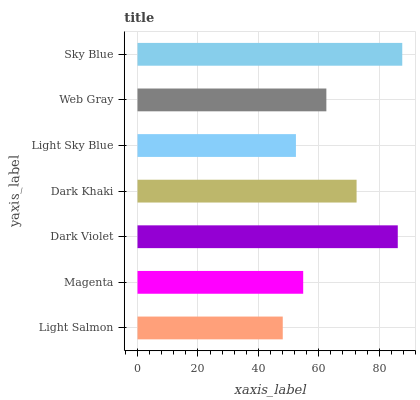Is Light Salmon the minimum?
Answer yes or no. Yes. Is Sky Blue the maximum?
Answer yes or no. Yes. Is Magenta the minimum?
Answer yes or no. No. Is Magenta the maximum?
Answer yes or no. No. Is Magenta greater than Light Salmon?
Answer yes or no. Yes. Is Light Salmon less than Magenta?
Answer yes or no. Yes. Is Light Salmon greater than Magenta?
Answer yes or no. No. Is Magenta less than Light Salmon?
Answer yes or no. No. Is Web Gray the high median?
Answer yes or no. Yes. Is Web Gray the low median?
Answer yes or no. Yes. Is Light Salmon the high median?
Answer yes or no. No. Is Sky Blue the low median?
Answer yes or no. No. 